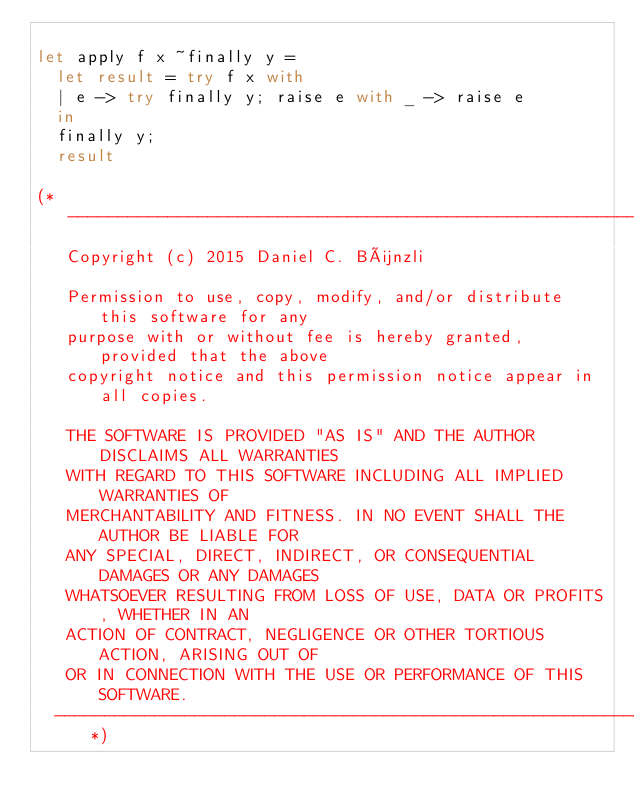<code> <loc_0><loc_0><loc_500><loc_500><_OCaml_>
let apply f x ~finally y =
  let result = try f x with
  | e -> try finally y; raise e with _ -> raise e
  in
  finally y;
  result

(*---------------------------------------------------------------------------
   Copyright (c) 2015 Daniel C. Bünzli

   Permission to use, copy, modify, and/or distribute this software for any
   purpose with or without fee is hereby granted, provided that the above
   copyright notice and this permission notice appear in all copies.

   THE SOFTWARE IS PROVIDED "AS IS" AND THE AUTHOR DISCLAIMS ALL WARRANTIES
   WITH REGARD TO THIS SOFTWARE INCLUDING ALL IMPLIED WARRANTIES OF
   MERCHANTABILITY AND FITNESS. IN NO EVENT SHALL THE AUTHOR BE LIABLE FOR
   ANY SPECIAL, DIRECT, INDIRECT, OR CONSEQUENTIAL DAMAGES OR ANY DAMAGES
   WHATSOEVER RESULTING FROM LOSS OF USE, DATA OR PROFITS, WHETHER IN AN
   ACTION OF CONTRACT, NEGLIGENCE OR OTHER TORTIOUS ACTION, ARISING OUT OF
   OR IN CONNECTION WITH THE USE OR PERFORMANCE OF THIS SOFTWARE.
  ---------------------------------------------------------------------------*)
</code> 